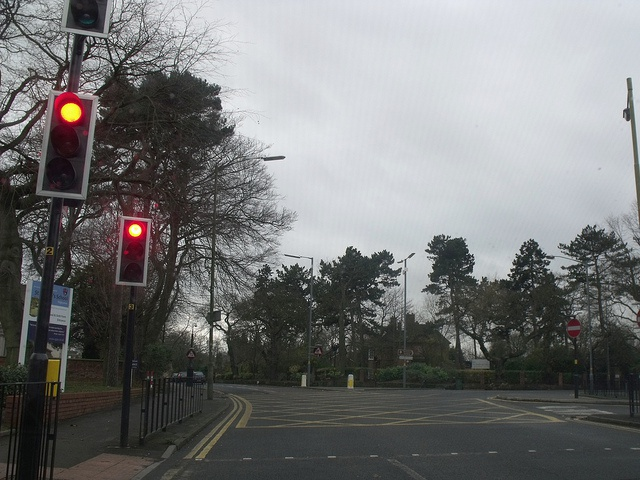Describe the objects in this image and their specific colors. I can see traffic light in black, gray, and maroon tones, traffic light in black, maroon, gray, and brown tones, traffic light in black, darkgray, and gray tones, stop sign in black, maroon, and gray tones, and car in black and gray tones in this image. 